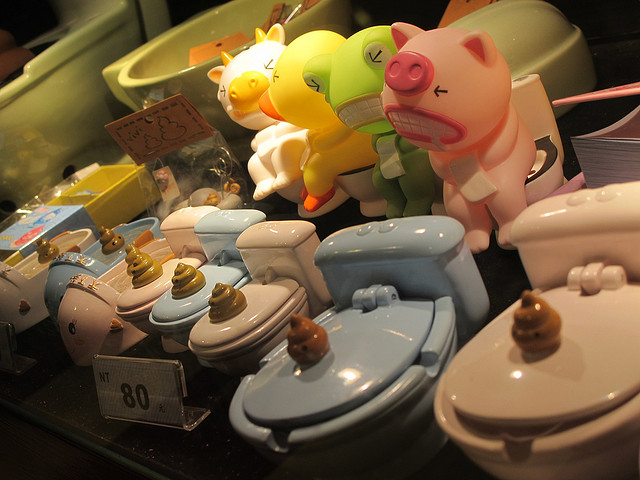Extract all visible text content from this image. 80 